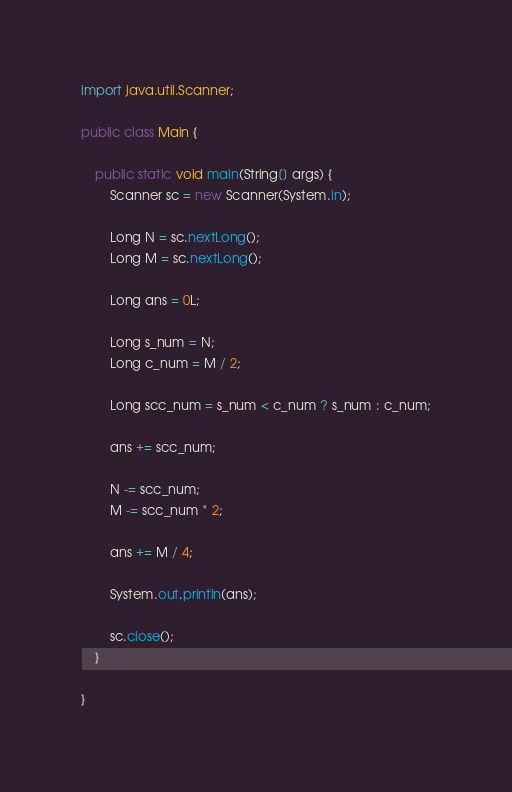<code> <loc_0><loc_0><loc_500><loc_500><_Java_>
import java.util.Scanner;

public class Main {

	public static void main(String[] args) {
		Scanner sc = new Scanner(System.in);

		Long N = sc.nextLong();
		Long M = sc.nextLong();

		Long ans = 0L;

		Long s_num = N;
		Long c_num = M / 2;

		Long scc_num = s_num < c_num ? s_num : c_num;

		ans += scc_num;

		N -= scc_num;
		M -= scc_num * 2;

		ans += M / 4;

		System.out.println(ans);

		sc.close();
	}

}
</code> 